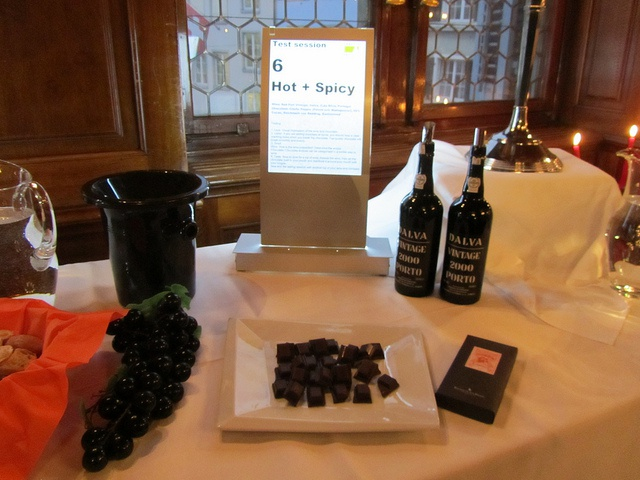Describe the objects in this image and their specific colors. I can see dining table in black and tan tones, cup in black, maroon, and gray tones, vase in black, maroon, and gray tones, bottle in black, maroon, and gray tones, and bottle in black, maroon, and gray tones in this image. 